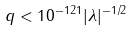Convert formula to latex. <formula><loc_0><loc_0><loc_500><loc_500>q < 1 0 ^ { - 1 2 1 } | \lambda | ^ { - 1 / 2 }</formula> 